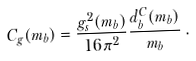Convert formula to latex. <formula><loc_0><loc_0><loc_500><loc_500>C _ { g } ( m _ { b } ) = \frac { g _ { s } ^ { 2 } ( m _ { b } ) } { 1 6 \pi ^ { 2 } } \frac { d ^ { C } _ { b } ( m _ { b } ) } { m _ { b } } \, .</formula> 